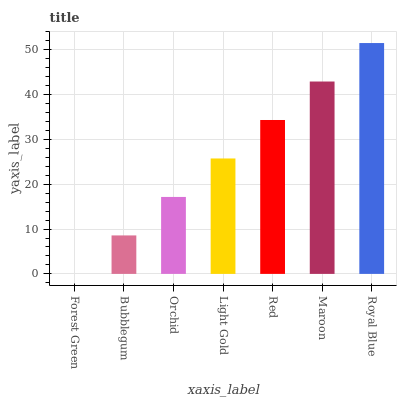Is Forest Green the minimum?
Answer yes or no. Yes. Is Royal Blue the maximum?
Answer yes or no. Yes. Is Bubblegum the minimum?
Answer yes or no. No. Is Bubblegum the maximum?
Answer yes or no. No. Is Bubblegum greater than Forest Green?
Answer yes or no. Yes. Is Forest Green less than Bubblegum?
Answer yes or no. Yes. Is Forest Green greater than Bubblegum?
Answer yes or no. No. Is Bubblegum less than Forest Green?
Answer yes or no. No. Is Light Gold the high median?
Answer yes or no. Yes. Is Light Gold the low median?
Answer yes or no. Yes. Is Forest Green the high median?
Answer yes or no. No. Is Maroon the low median?
Answer yes or no. No. 